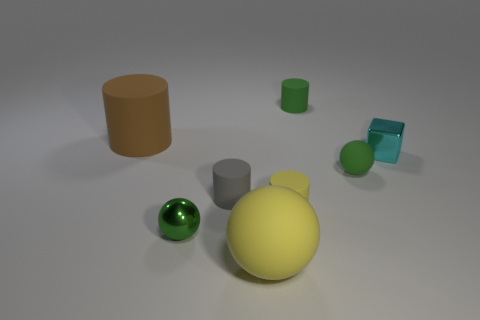Add 1 big purple shiny balls. How many objects exist? 9 Subtract all blocks. How many objects are left? 7 Subtract 0 purple cylinders. How many objects are left? 8 Subtract all gray objects. Subtract all tiny cyan objects. How many objects are left? 6 Add 3 small things. How many small things are left? 9 Add 3 small green matte cylinders. How many small green matte cylinders exist? 4 